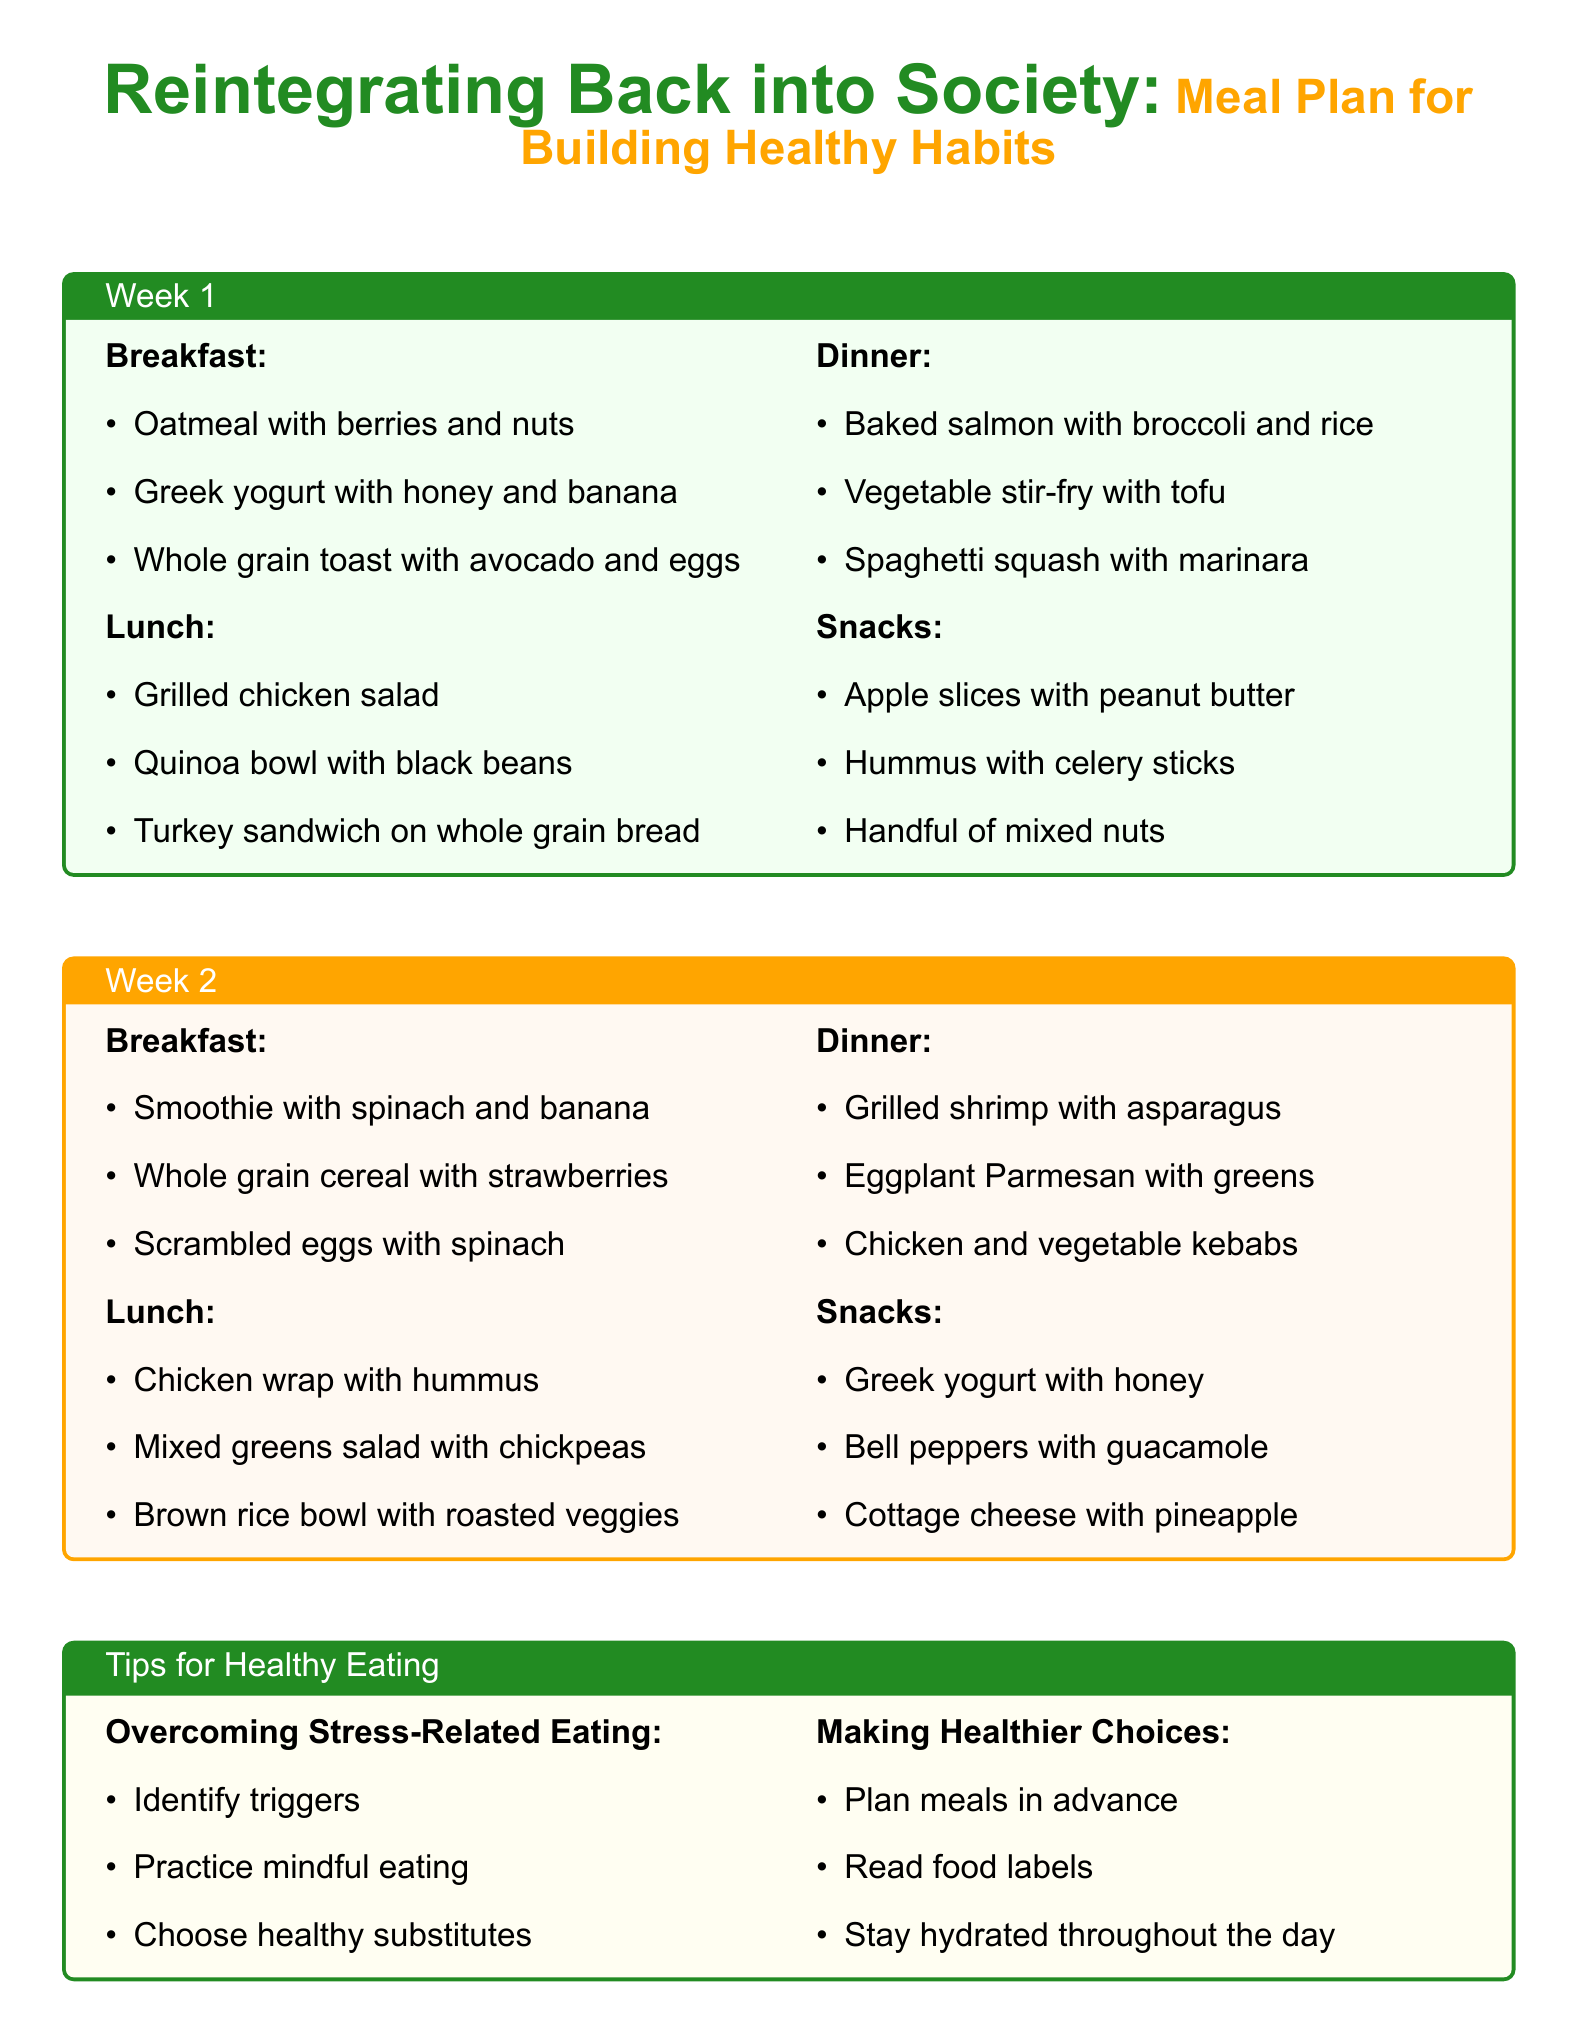what are the breakfast options for Week 1? The breakfast options listed in Week 1 include oatmeal with berries and nuts, Greek yogurt with honey and banana, and whole grain toast with avocado and eggs.
Answer: oatmeal with berries and nuts, Greek yogurt with honey and banana, whole grain toast with avocado and eggs how many dinner options are provided for Week 2? Week 2 includes three dinner options: grilled shrimp with asparagus, eggplant Parmesan with greens, and chicken and vegetable kebabs.
Answer: 3 what is one of the tips for overcoming stress-related eating? One of the tips listed for overcoming stress-related eating is to identify triggers.
Answer: identify triggers which meal includes black beans in Week 1? The lunch option that includes black beans in Week 1 is the quinoa bowl with black beans.
Answer: quinoa bowl with black beans what is a suggestion for making healthier choices? One suggestion for making healthier choices is to plan meals in advance.
Answer: plan meals in advance which snack option is recommended for Week 1? One of the recommended snack options for Week 1 is apple slices with peanut butter.
Answer: apple slices with peanut butter how many different meals are provided in total for Week 1? Week 1 has 12 different meals listed: 3 breakfast, 3 lunch, 3 dinner, and 3 snacks.
Answer: 12 what type of food is included in the dinner options for Week 1? The dinner options for Week 1 include baked salmon, vegetable stir-fry, and spaghetti squash.
Answer: baked salmon, vegetable stir-fry, spaghetti squash what category do the tips for healthy eating fall under? The tips for healthy eating are categorized into two sections: overcoming stress-related eating and making healthier choices.
Answer: tips for healthy eating 